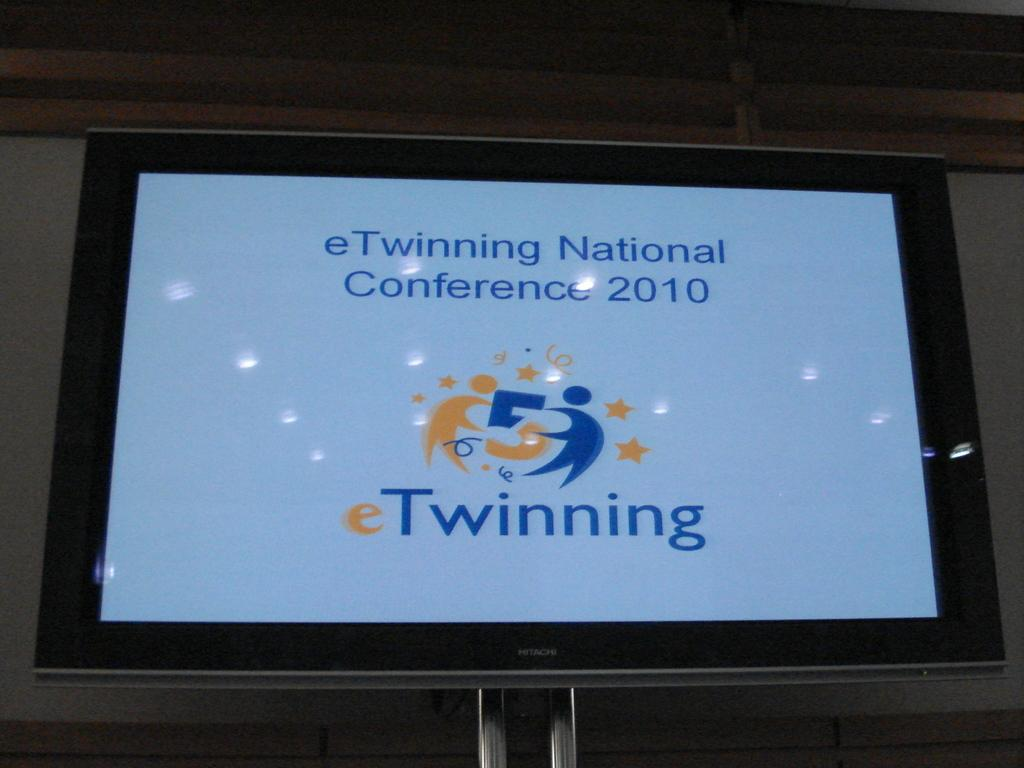<image>
Share a concise interpretation of the image provided. A monitor advertises the eTwinning National Conference in the year 2010. 